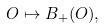<formula> <loc_0><loc_0><loc_500><loc_500>O \mapsto B _ { + } ( O ) ,</formula> 